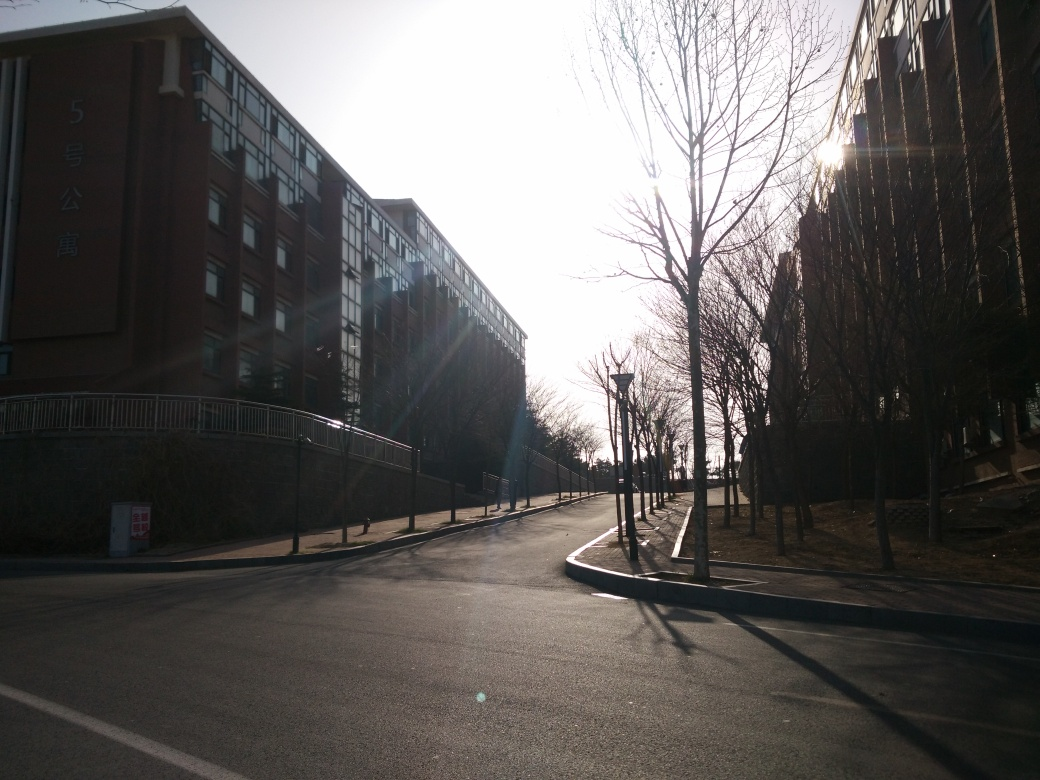What time of day does this photo appear to be taken, and why? The photo appears to be taken in the early morning or late afternoon, as suggested by the long shadows cast by the trees and the low angle of the sun, which is visible in the frame. The warm tone of the sunlight and the quietness of the scene support this indication of the time of day. 